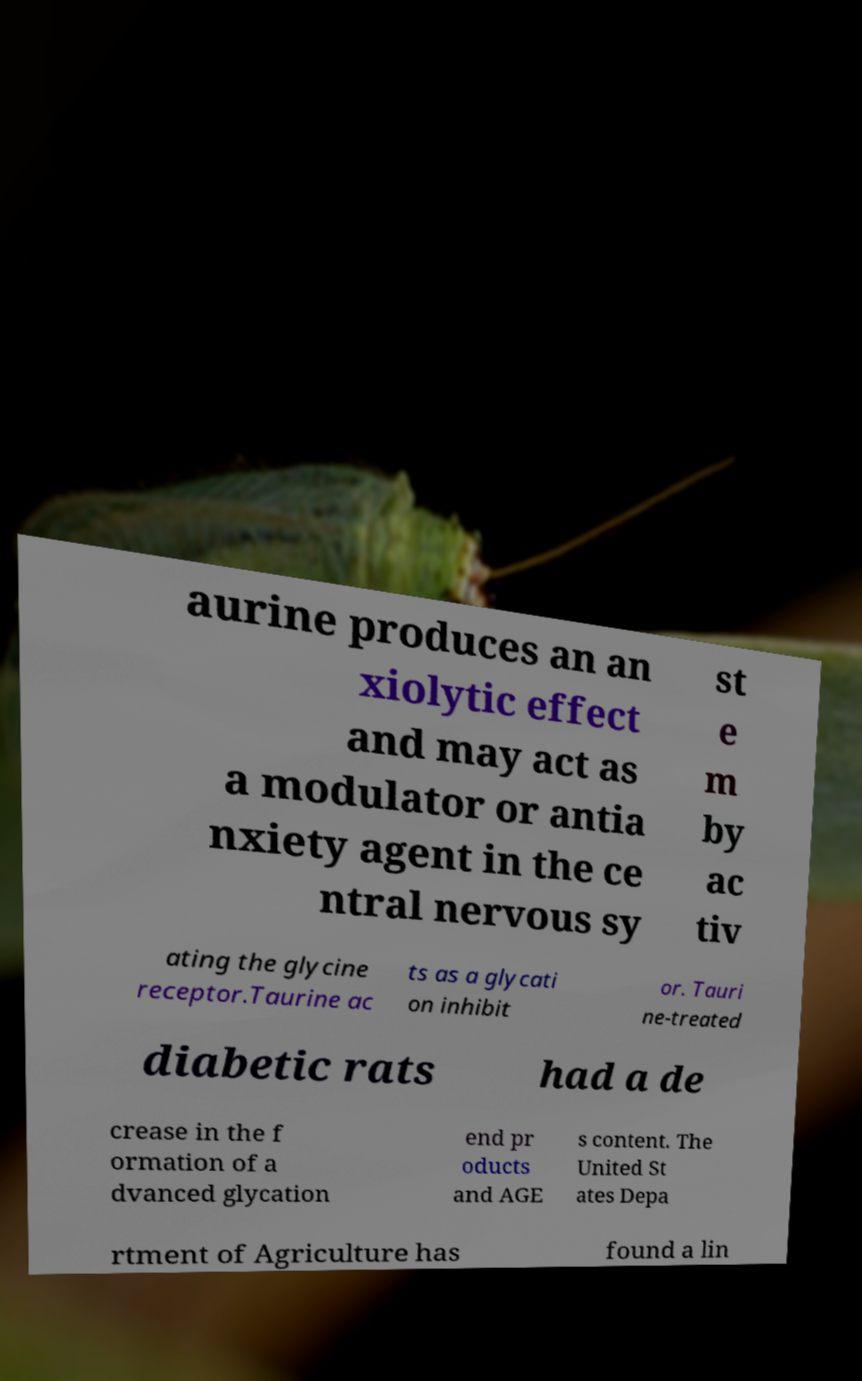For documentation purposes, I need the text within this image transcribed. Could you provide that? aurine produces an an xiolytic effect and may act as a modulator or antia nxiety agent in the ce ntral nervous sy st e m by ac tiv ating the glycine receptor.Taurine ac ts as a glycati on inhibit or. Tauri ne-treated diabetic rats had a de crease in the f ormation of a dvanced glycation end pr oducts and AGE s content. The United St ates Depa rtment of Agriculture has found a lin 